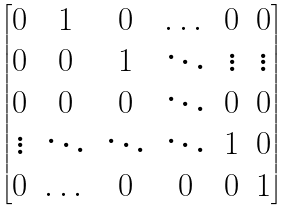<formula> <loc_0><loc_0><loc_500><loc_500>\begin{bmatrix} 0 & 1 & 0 & \dots & 0 & 0 \\ 0 & 0 & 1 & \ddots & \vdots & \vdots \\ 0 & 0 & 0 & \ddots & 0 & 0 \\ \vdots & \ddots & \ddots & \ddots & 1 & 0 \\ 0 & \dots & 0 & 0 & 0 & 1 \\ \end{bmatrix}</formula> 